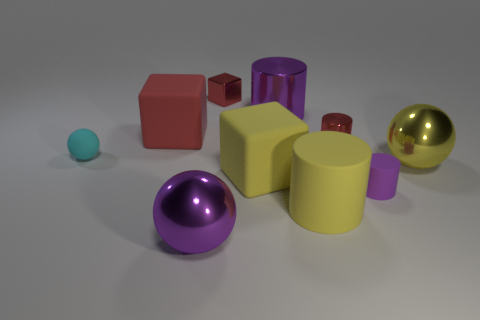How many tiny red things have the same shape as the big red thing?
Your answer should be compact. 1. What number of large red rubber things are there?
Keep it short and to the point. 1. There is a big rubber thing in front of the tiny purple matte cylinder; is it the same shape as the small cyan rubber thing?
Your answer should be compact. No. What is the material of the red block that is the same size as the purple rubber object?
Provide a short and direct response. Metal. Is there a big cylinder that has the same material as the purple ball?
Give a very brief answer. Yes. Do the yellow shiny thing and the tiny object that is behind the big red rubber object have the same shape?
Your answer should be very brief. No. How many rubber things are behind the large yellow matte block and on the right side of the purple sphere?
Keep it short and to the point. 0. Is the material of the tiny purple cylinder the same as the big cylinder behind the tiny cyan sphere?
Give a very brief answer. No. Are there the same number of red rubber cubes that are in front of the large yellow block and tiny gray cylinders?
Give a very brief answer. Yes. There is a tiny rubber object that is on the left side of the purple metal ball; what is its color?
Offer a very short reply. Cyan. 